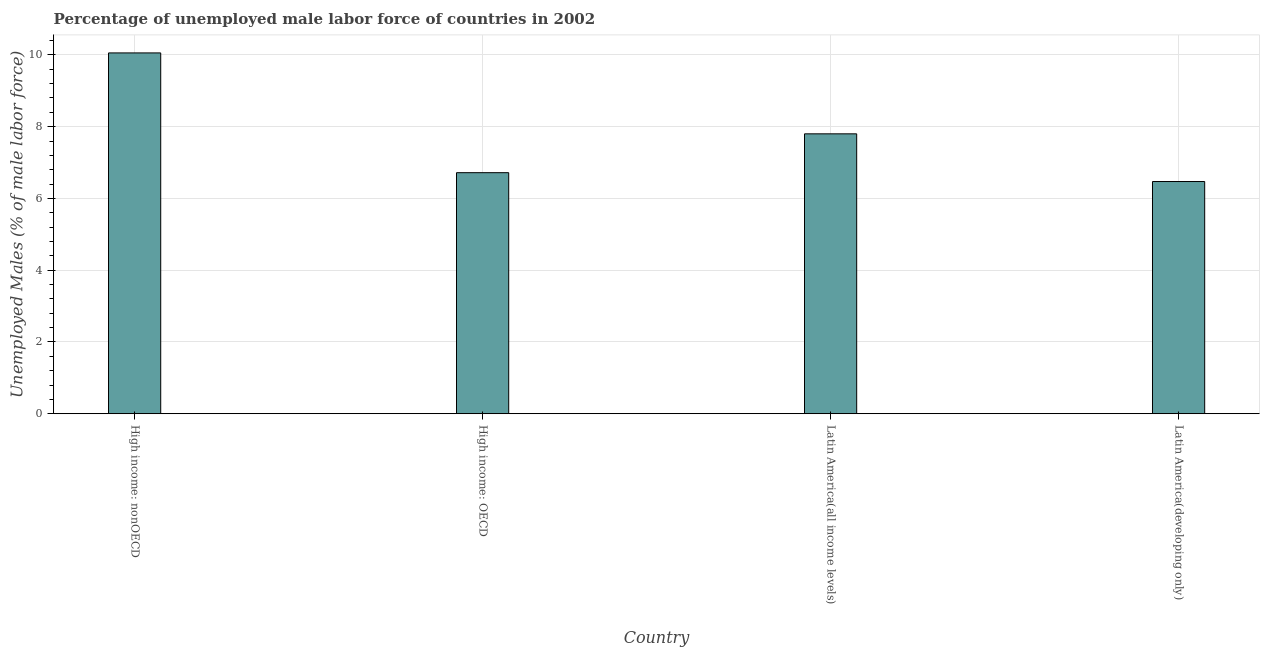Does the graph contain any zero values?
Your answer should be compact. No. Does the graph contain grids?
Ensure brevity in your answer.  Yes. What is the title of the graph?
Keep it short and to the point. Percentage of unemployed male labor force of countries in 2002. What is the label or title of the X-axis?
Offer a terse response. Country. What is the label or title of the Y-axis?
Offer a terse response. Unemployed Males (% of male labor force). What is the total unemployed male labour force in Latin America(all income levels)?
Your response must be concise. 7.8. Across all countries, what is the maximum total unemployed male labour force?
Offer a terse response. 10.05. Across all countries, what is the minimum total unemployed male labour force?
Provide a short and direct response. 6.47. In which country was the total unemployed male labour force maximum?
Give a very brief answer. High income: nonOECD. In which country was the total unemployed male labour force minimum?
Ensure brevity in your answer.  Latin America(developing only). What is the sum of the total unemployed male labour force?
Make the answer very short. 31.04. What is the difference between the total unemployed male labour force in High income: OECD and High income: nonOECD?
Keep it short and to the point. -3.34. What is the average total unemployed male labour force per country?
Offer a terse response. 7.76. What is the median total unemployed male labour force?
Give a very brief answer. 7.26. What is the ratio of the total unemployed male labour force in High income: nonOECD to that in Latin America(developing only)?
Provide a short and direct response. 1.55. Is the difference between the total unemployed male labour force in High income: OECD and Latin America(all income levels) greater than the difference between any two countries?
Ensure brevity in your answer.  No. What is the difference between the highest and the second highest total unemployed male labour force?
Offer a terse response. 2.25. Is the sum of the total unemployed male labour force in Latin America(all income levels) and Latin America(developing only) greater than the maximum total unemployed male labour force across all countries?
Ensure brevity in your answer.  Yes. What is the difference between the highest and the lowest total unemployed male labour force?
Ensure brevity in your answer.  3.58. In how many countries, is the total unemployed male labour force greater than the average total unemployed male labour force taken over all countries?
Offer a terse response. 2. How many bars are there?
Ensure brevity in your answer.  4. Are all the bars in the graph horizontal?
Offer a terse response. No. How many countries are there in the graph?
Your answer should be compact. 4. What is the difference between two consecutive major ticks on the Y-axis?
Your response must be concise. 2. What is the Unemployed Males (% of male labor force) in High income: nonOECD?
Your answer should be very brief. 10.05. What is the Unemployed Males (% of male labor force) of High income: OECD?
Provide a succinct answer. 6.72. What is the Unemployed Males (% of male labor force) of Latin America(all income levels)?
Your answer should be very brief. 7.8. What is the Unemployed Males (% of male labor force) in Latin America(developing only)?
Your answer should be compact. 6.47. What is the difference between the Unemployed Males (% of male labor force) in High income: nonOECD and High income: OECD?
Offer a terse response. 3.34. What is the difference between the Unemployed Males (% of male labor force) in High income: nonOECD and Latin America(all income levels)?
Your answer should be compact. 2.26. What is the difference between the Unemployed Males (% of male labor force) in High income: nonOECD and Latin America(developing only)?
Make the answer very short. 3.58. What is the difference between the Unemployed Males (% of male labor force) in High income: OECD and Latin America(all income levels)?
Offer a very short reply. -1.08. What is the difference between the Unemployed Males (% of male labor force) in High income: OECD and Latin America(developing only)?
Your response must be concise. 0.25. What is the difference between the Unemployed Males (% of male labor force) in Latin America(all income levels) and Latin America(developing only)?
Make the answer very short. 1.33. What is the ratio of the Unemployed Males (% of male labor force) in High income: nonOECD to that in High income: OECD?
Ensure brevity in your answer.  1.5. What is the ratio of the Unemployed Males (% of male labor force) in High income: nonOECD to that in Latin America(all income levels)?
Your answer should be very brief. 1.29. What is the ratio of the Unemployed Males (% of male labor force) in High income: nonOECD to that in Latin America(developing only)?
Offer a terse response. 1.55. What is the ratio of the Unemployed Males (% of male labor force) in High income: OECD to that in Latin America(all income levels)?
Provide a short and direct response. 0.86. What is the ratio of the Unemployed Males (% of male labor force) in High income: OECD to that in Latin America(developing only)?
Offer a terse response. 1.04. What is the ratio of the Unemployed Males (% of male labor force) in Latin America(all income levels) to that in Latin America(developing only)?
Your answer should be very brief. 1.21. 